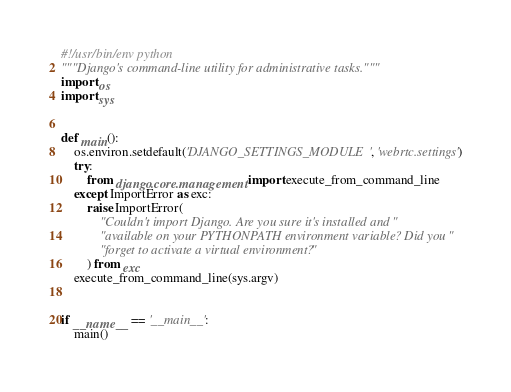Convert code to text. <code><loc_0><loc_0><loc_500><loc_500><_Python_>#!/usr/bin/env python
"""Django's command-line utility for administrative tasks."""
import os
import sys


def main():
    os.environ.setdefault('DJANGO_SETTINGS_MODULE', 'webrtc.settings')
    try:
        from django.core.management import execute_from_command_line
    except ImportError as exc:
        raise ImportError(
            "Couldn't import Django. Are you sure it's installed and "
            "available on your PYTHONPATH environment variable? Did you "
            "forget to activate a virtual environment?"
        ) from exc
    execute_from_command_line(sys.argv)


if __name__ == '__main__':
    main()
</code> 